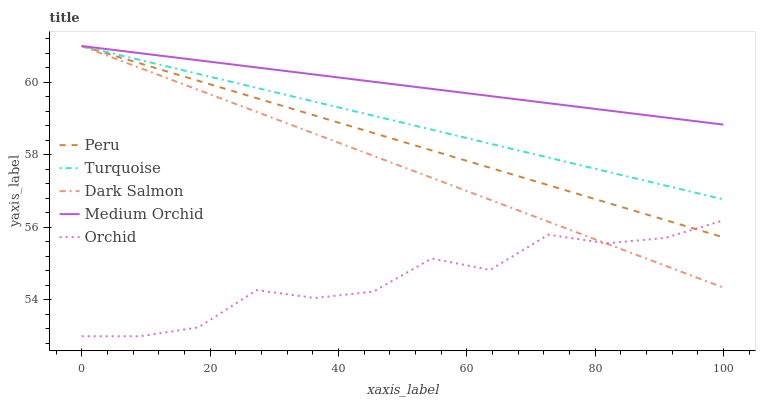Does Orchid have the minimum area under the curve?
Answer yes or no. Yes. Does Medium Orchid have the maximum area under the curve?
Answer yes or no. Yes. Does Dark Salmon have the minimum area under the curve?
Answer yes or no. No. Does Dark Salmon have the maximum area under the curve?
Answer yes or no. No. Is Turquoise the smoothest?
Answer yes or no. Yes. Is Orchid the roughest?
Answer yes or no. Yes. Is Medium Orchid the smoothest?
Answer yes or no. No. Is Medium Orchid the roughest?
Answer yes or no. No. Does Orchid have the lowest value?
Answer yes or no. Yes. Does Dark Salmon have the lowest value?
Answer yes or no. No. Does Peru have the highest value?
Answer yes or no. Yes. Does Orchid have the highest value?
Answer yes or no. No. Is Orchid less than Medium Orchid?
Answer yes or no. Yes. Is Medium Orchid greater than Orchid?
Answer yes or no. Yes. Does Dark Salmon intersect Orchid?
Answer yes or no. Yes. Is Dark Salmon less than Orchid?
Answer yes or no. No. Is Dark Salmon greater than Orchid?
Answer yes or no. No. Does Orchid intersect Medium Orchid?
Answer yes or no. No. 